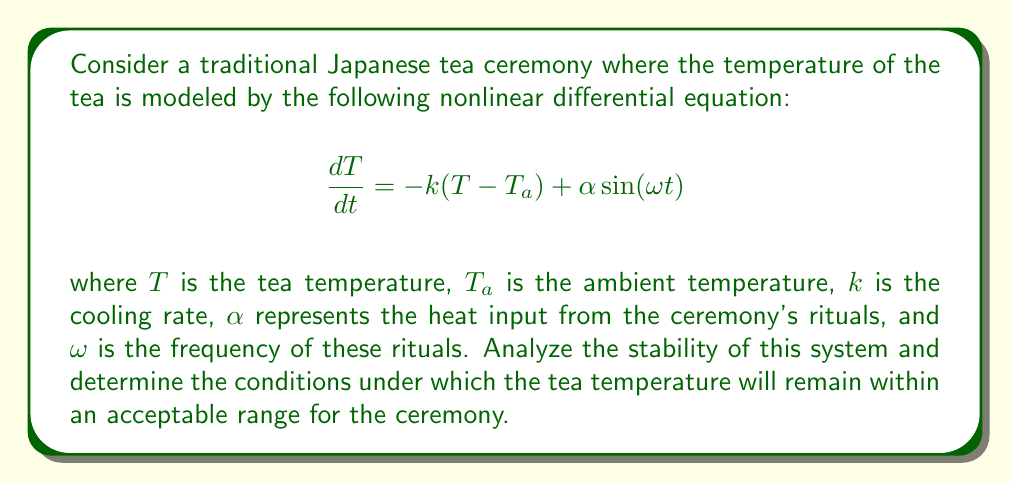Provide a solution to this math problem. To analyze the stability of this nonlinear dynamical system, we'll follow these steps:

1) First, identify the equilibrium points by setting $\frac{dT}{dt} = 0$:

   $$0 = -k(T - T_a) + \alpha \sin(\omega t)$$

   This equation doesn't have a fixed equilibrium point due to the time-dependent term.

2) We can rewrite the equation as:

   $$\frac{dT}{dt} + kT = kT_a + \alpha \sin(\omega t)$$

3) This is a first-order linear non-homogeneous differential equation. The general solution is the sum of the homogeneous solution and a particular solution.

4) The homogeneous solution is:

   $$T_h(t) = Ce^{-kt}$$

   where $C$ is a constant.

5) A particular solution has the form:

   $$T_p(t) = A \cos(\omega t) + B \sin(\omega t) + T_a$$

6) Substituting this into the original equation and solving for $A$ and $B$:

   $$A = \frac{k\alpha\omega}{k^2 + \omega^2}, \quad B = \frac{k^2\alpha}{k^2 + \omega^2}$$

7) The general solution is:

   $$T(t) = Ce^{-kt} + \frac{k\alpha\omega}{k^2 + \omega^2}\cos(\omega t) + \frac{k^2\alpha}{k^2 + \omega^2}\sin(\omega t) + T_a$$

8) As $t \to \infty$, the $e^{-kt}$ term approaches zero, so the long-term behavior is:

   $$T(t) \approx \frac{k\alpha\omega}{k^2 + \omega^2}\cos(\omega t) + \frac{k^2\alpha}{k^2 + \omega^2}\sin(\omega t) + T_a$$

9) The amplitude of the oscillation around $T_a$ is:

   $$A = \sqrt{\left(\frac{k\alpha\omega}{k^2 + \omega^2}\right)^2 + \left(\frac{k^2\alpha}{k^2 + \omega^2}\right)^2} = \frac{\alpha}{\sqrt{k^2 + \omega^2}}$$

10) For stability in the context of the tea ceremony, we want this amplitude to be small. This occurs when:
    - $k$ is large (rapid cooling)
    - $\omega$ is large (frequent rituals)
    - $\alpha$ is small (gentle heating)

The tea temperature will remain within an acceptable range if $A$ is less than the allowed temperature deviation from $T_a$.
Answer: The system is stable with oscillations around $T_a$. Temperature remains acceptable if $\frac{\alpha}{\sqrt{k^2 + \omega^2}} < $ allowed deviation. 